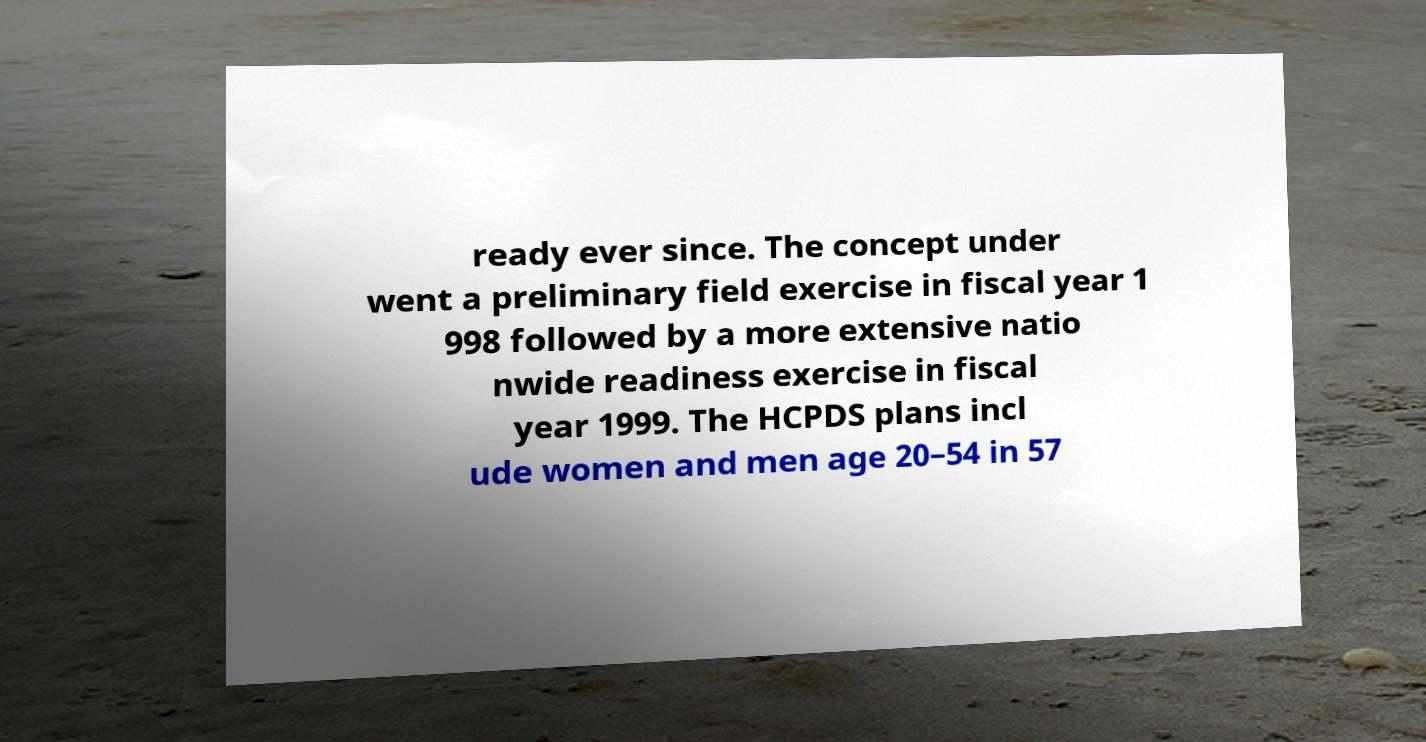For documentation purposes, I need the text within this image transcribed. Could you provide that? ready ever since. The concept under went a preliminary field exercise in fiscal year 1 998 followed by a more extensive natio nwide readiness exercise in fiscal year 1999. The HCPDS plans incl ude women and men age 20–54 in 57 